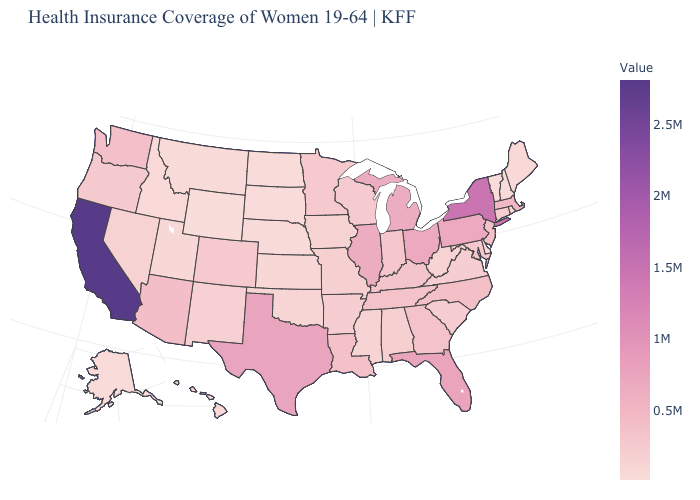Does California have the highest value in the USA?
Give a very brief answer. Yes. Which states have the lowest value in the USA?
Quick response, please. Wyoming. Does Wyoming have the lowest value in the USA?
Quick response, please. Yes. Among the states that border Illinois , does Kentucky have the highest value?
Be succinct. Yes. Which states hav the highest value in the MidWest?
Concise answer only. Ohio. Does Iowa have the highest value in the USA?
Keep it brief. No. Does New York have the highest value in the Northeast?
Give a very brief answer. Yes. 